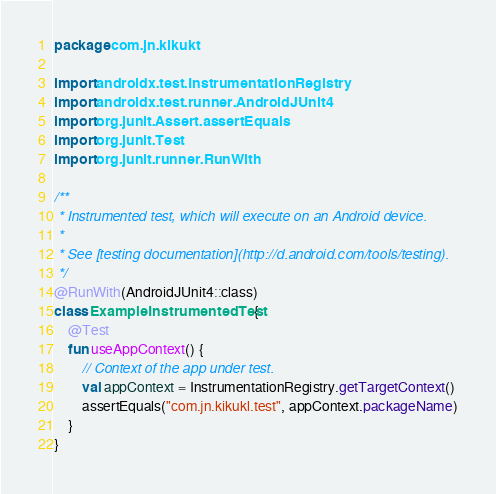Convert code to text. <code><loc_0><loc_0><loc_500><loc_500><_Kotlin_>package com.jn.kikukt

import androidx.test.InstrumentationRegistry
import androidx.test.runner.AndroidJUnit4
import org.junit.Assert.assertEquals
import org.junit.Test
import org.junit.runner.RunWith

/**
 * Instrumented test, which will execute on an Android device.
 *
 * See [testing documentation](http://d.android.com/tools/testing).
 */
@RunWith(AndroidJUnit4::class)
class ExampleInstrumentedTest {
    @Test
    fun useAppContext() {
        // Context of the app under test.
        val appContext = InstrumentationRegistry.getTargetContext()
        assertEquals("com.jn.kikukl.test", appContext.packageName)
    }
}
</code> 